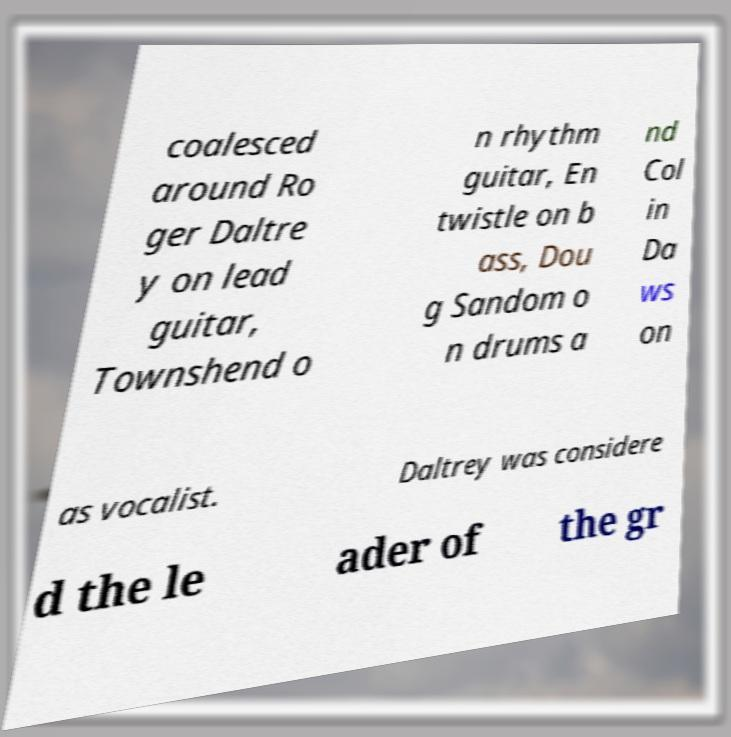Can you read and provide the text displayed in the image?This photo seems to have some interesting text. Can you extract and type it out for me? coalesced around Ro ger Daltre y on lead guitar, Townshend o n rhythm guitar, En twistle on b ass, Dou g Sandom o n drums a nd Col in Da ws on as vocalist. Daltrey was considere d the le ader of the gr 